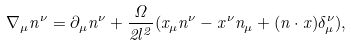<formula> <loc_0><loc_0><loc_500><loc_500>\nabla _ { \mu } n ^ { \nu } = \partial _ { \mu } n ^ { \nu } + \frac { \Omega } { 2 l ^ { 2 } } ( x _ { \mu } n ^ { \nu } - x ^ { \nu } n _ { \mu } + ( n \cdot x ) \delta ^ { \nu } _ { \mu } ) ,</formula> 